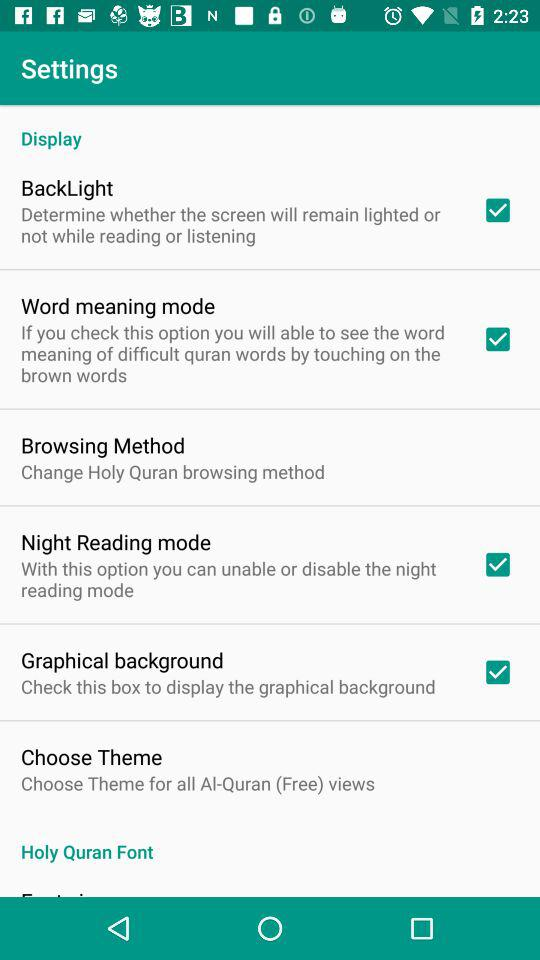What can you infer about the app based on the settings options? Based on the settings options visible in the screenshot, the app appears to be centered around reading or studying the Quran. Features like 'Word meaning mode' suggest it provides educational resources for understanding difficult words. The 'Night Reading mode' indicates care for users' reading comfort in low-light conditions, and 'Graphical background' might enhance the visual appeal of the app. 